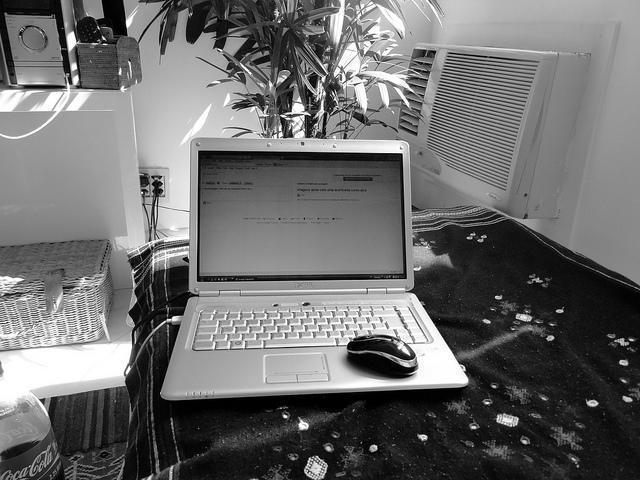Why would someone sit at this area?
Indicate the correct response by choosing from the four available options to answer the question.
Options: Wash, work, clean, eat. Work. 